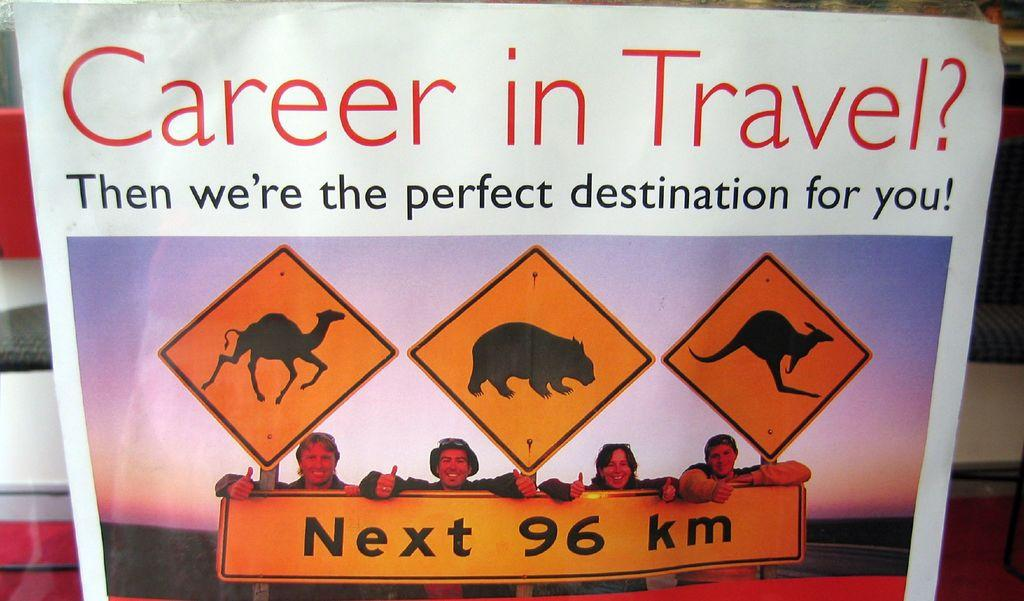<image>
Relay a brief, clear account of the picture shown. An advertisement with the title, "Career in Travel?" 